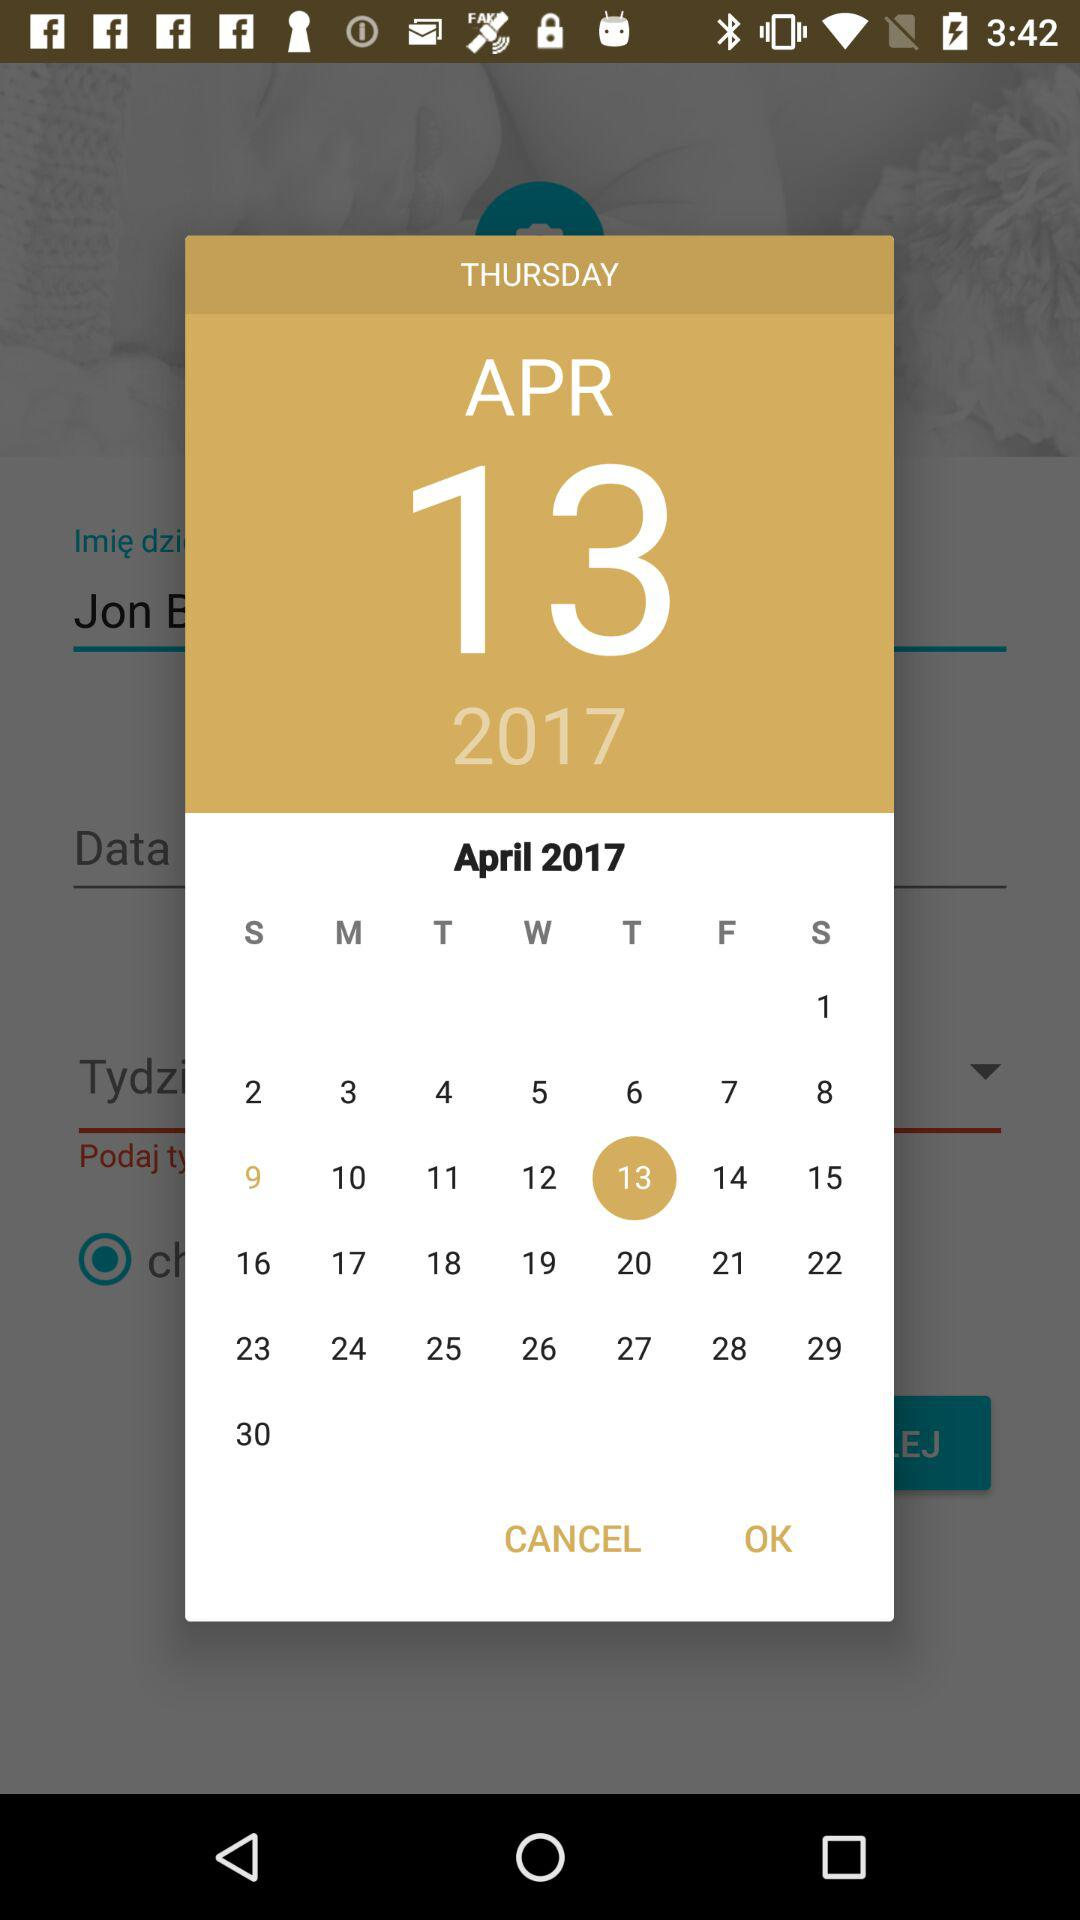What day falls on April 13, 2017? The day is Thursday. 